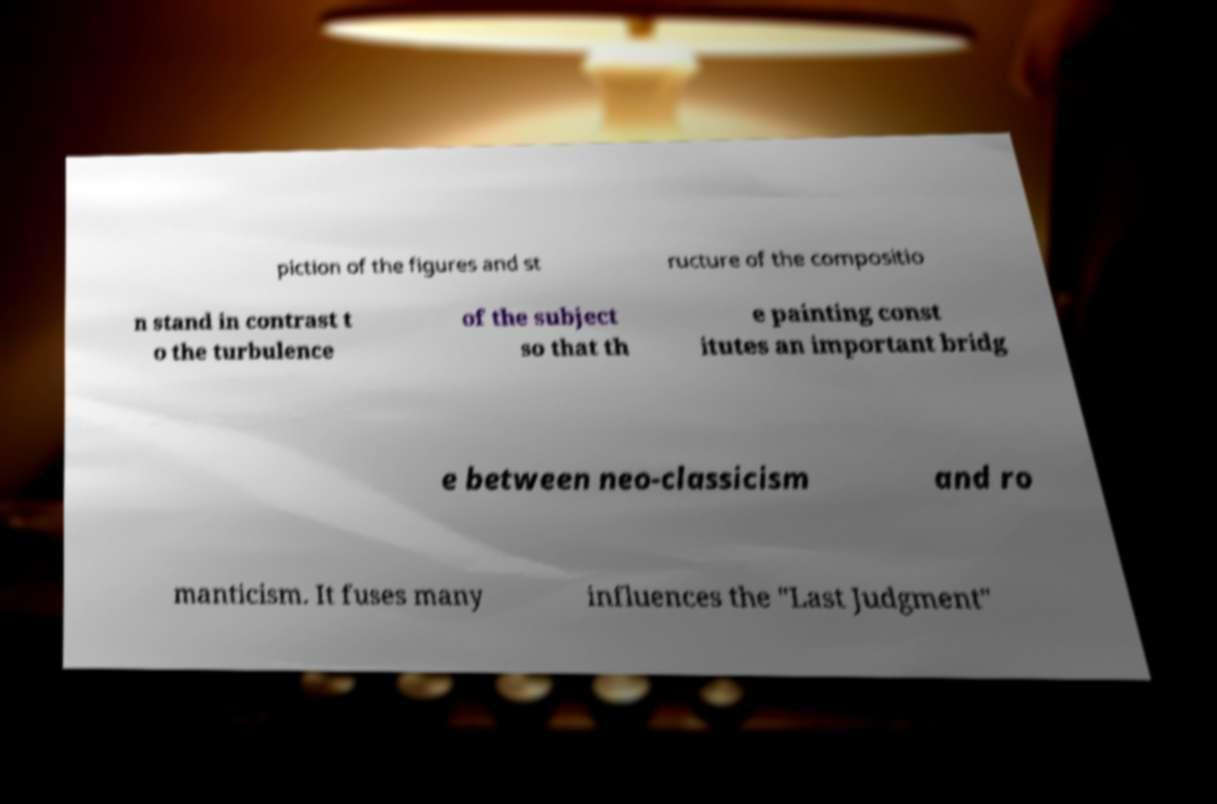Please identify and transcribe the text found in this image. piction of the figures and st ructure of the compositio n stand in contrast t o the turbulence of the subject so that th e painting const itutes an important bridg e between neo-classicism and ro manticism. It fuses many influences the "Last Judgment" 